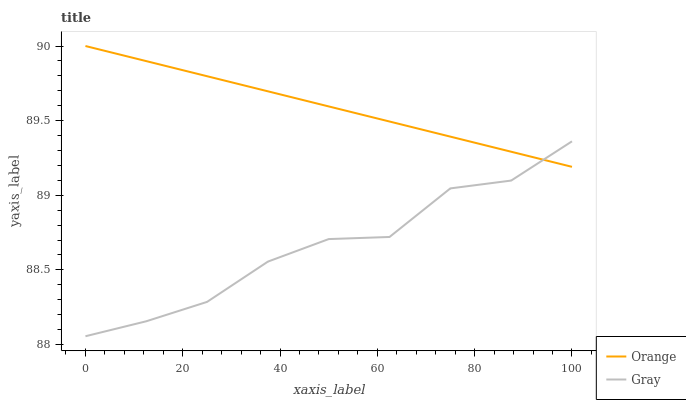Does Gray have the minimum area under the curve?
Answer yes or no. Yes. Does Orange have the maximum area under the curve?
Answer yes or no. Yes. Does Gray have the maximum area under the curve?
Answer yes or no. No. Is Orange the smoothest?
Answer yes or no. Yes. Is Gray the roughest?
Answer yes or no. Yes. Is Gray the smoothest?
Answer yes or no. No. Does Gray have the highest value?
Answer yes or no. No. 